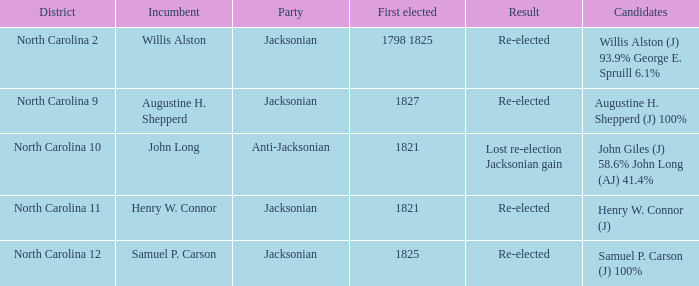What transpired as a result of the initial election that occurred in the 1798-1825 period? Re-elected. Could you parse the entire table as a dict? {'header': ['District', 'Incumbent', 'Party', 'First elected', 'Result', 'Candidates'], 'rows': [['North Carolina 2', 'Willis Alston', 'Jacksonian', '1798 1825', 'Re-elected', 'Willis Alston (J) 93.9% George E. Spruill 6.1%'], ['North Carolina 9', 'Augustine H. Shepperd', 'Jacksonian', '1827', 'Re-elected', 'Augustine H. Shepperd (J) 100%'], ['North Carolina 10', 'John Long', 'Anti-Jacksonian', '1821', 'Lost re-election Jacksonian gain', 'John Giles (J) 58.6% John Long (AJ) 41.4%'], ['North Carolina 11', 'Henry W. Connor', 'Jacksonian', '1821', 'Re-elected', 'Henry W. Connor (J)'], ['North Carolina 12', 'Samuel P. Carson', 'Jacksonian', '1825', 'Re-elected', 'Samuel P. Carson (J) 100%']]} 